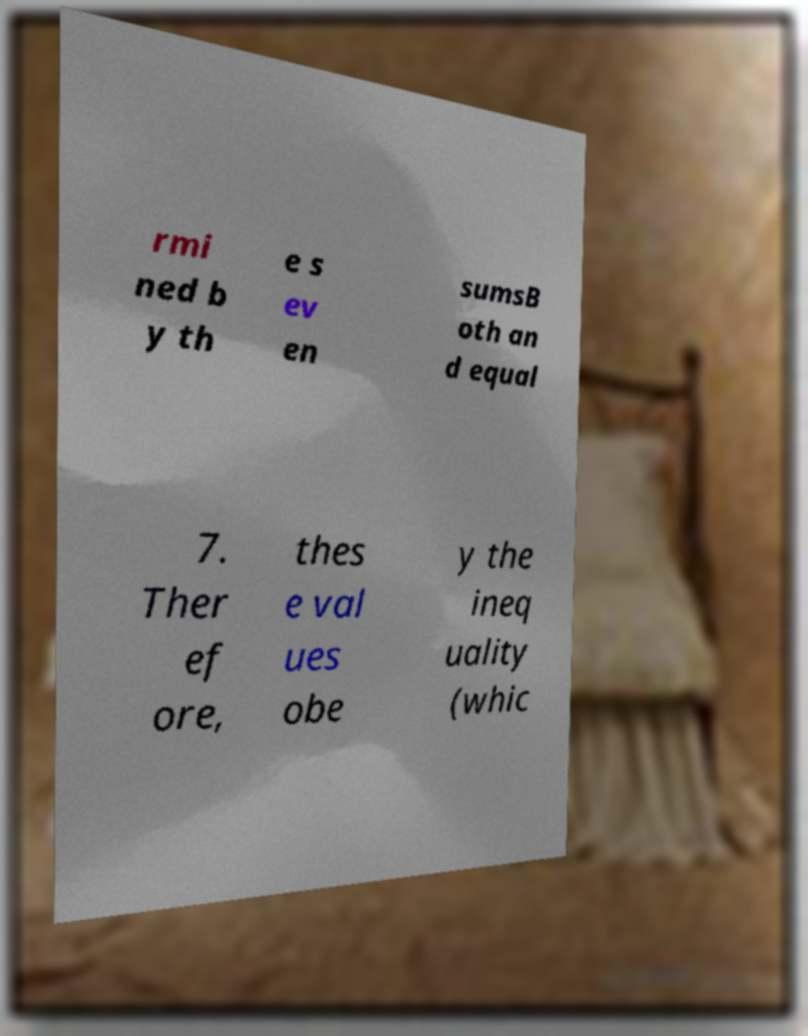Please read and relay the text visible in this image. What does it say? rmi ned b y th e s ev en sumsB oth an d equal 7. Ther ef ore, thes e val ues obe y the ineq uality (whic 